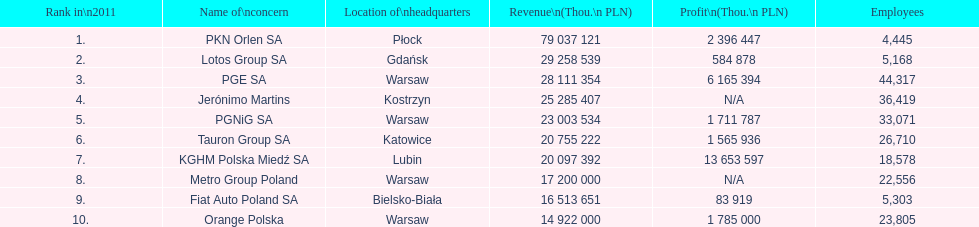What corporation is the only one with an income higher than 75,000,000 thou. pln? PKN Orlen SA. 